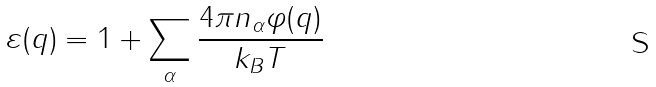<formula> <loc_0><loc_0><loc_500><loc_500>\varepsilon ( q ) = 1 + \sum _ { \alpha } \frac { 4 \pi n _ { \alpha } \varphi ( q ) } { k _ { B } T }</formula> 